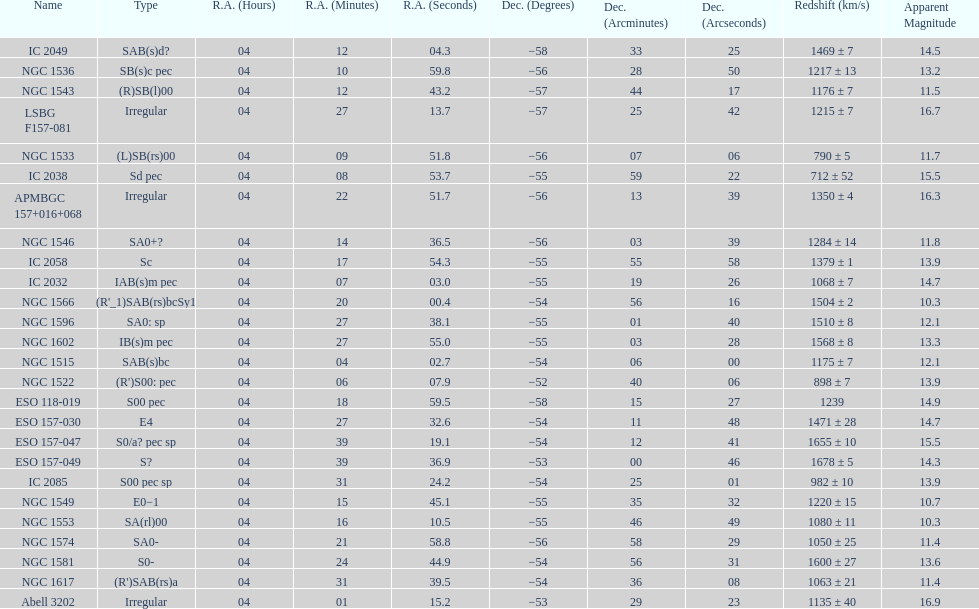What number of "irregular" types are there? 3. 